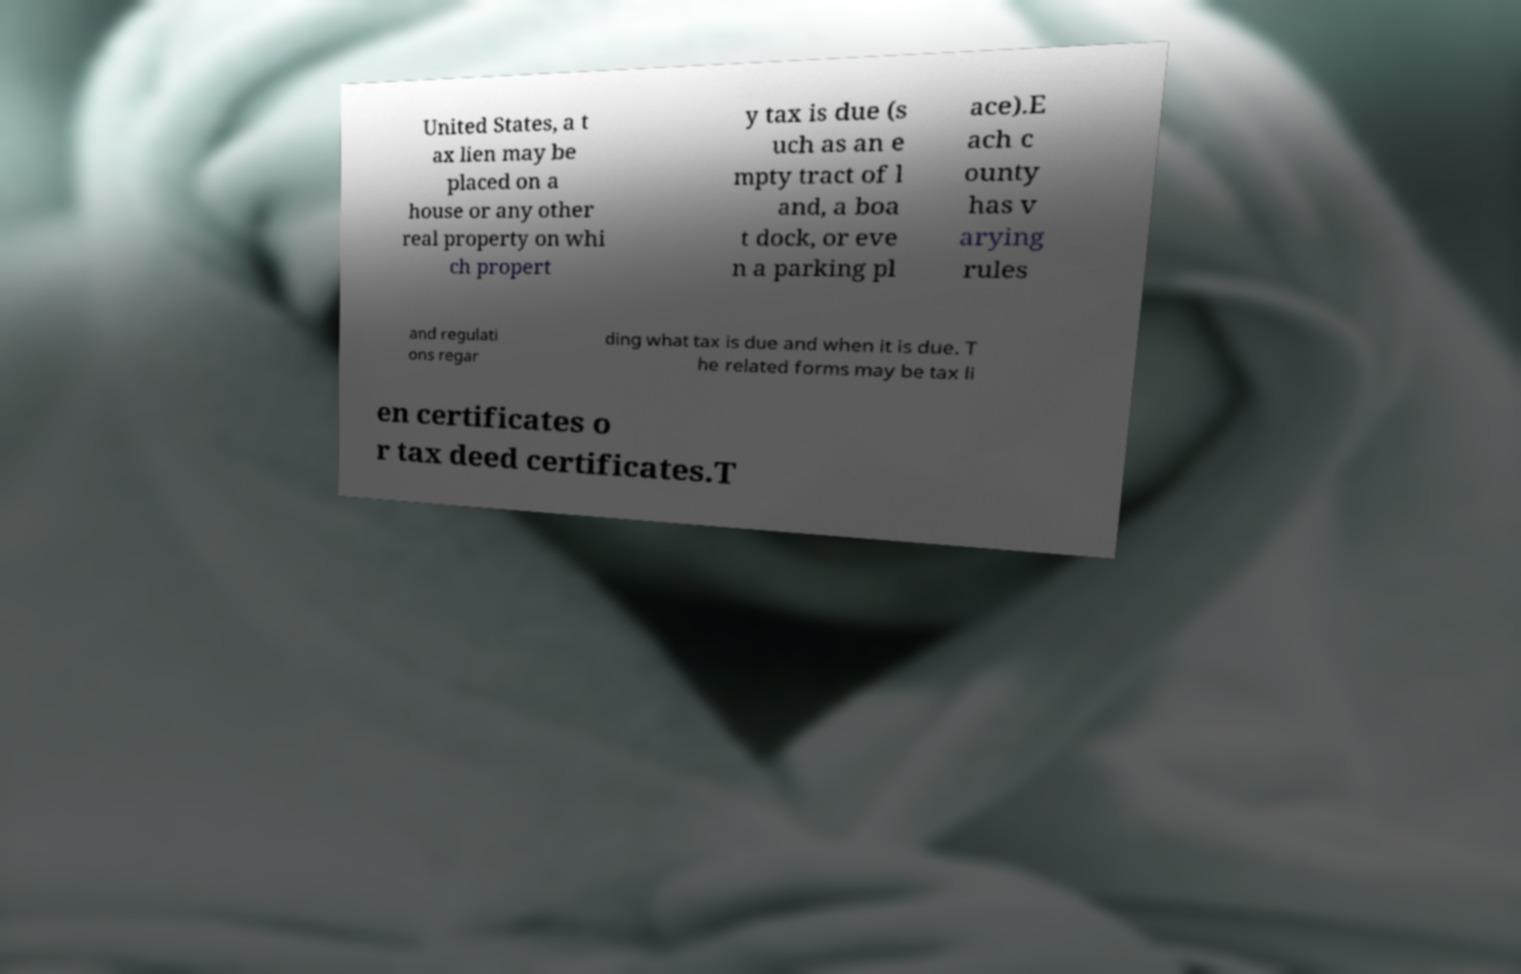Could you assist in decoding the text presented in this image and type it out clearly? United States, a t ax lien may be placed on a house or any other real property on whi ch propert y tax is due (s uch as an e mpty tract of l and, a boa t dock, or eve n a parking pl ace).E ach c ounty has v arying rules and regulati ons regar ding what tax is due and when it is due. T he related forms may be tax li en certificates o r tax deed certificates.T 